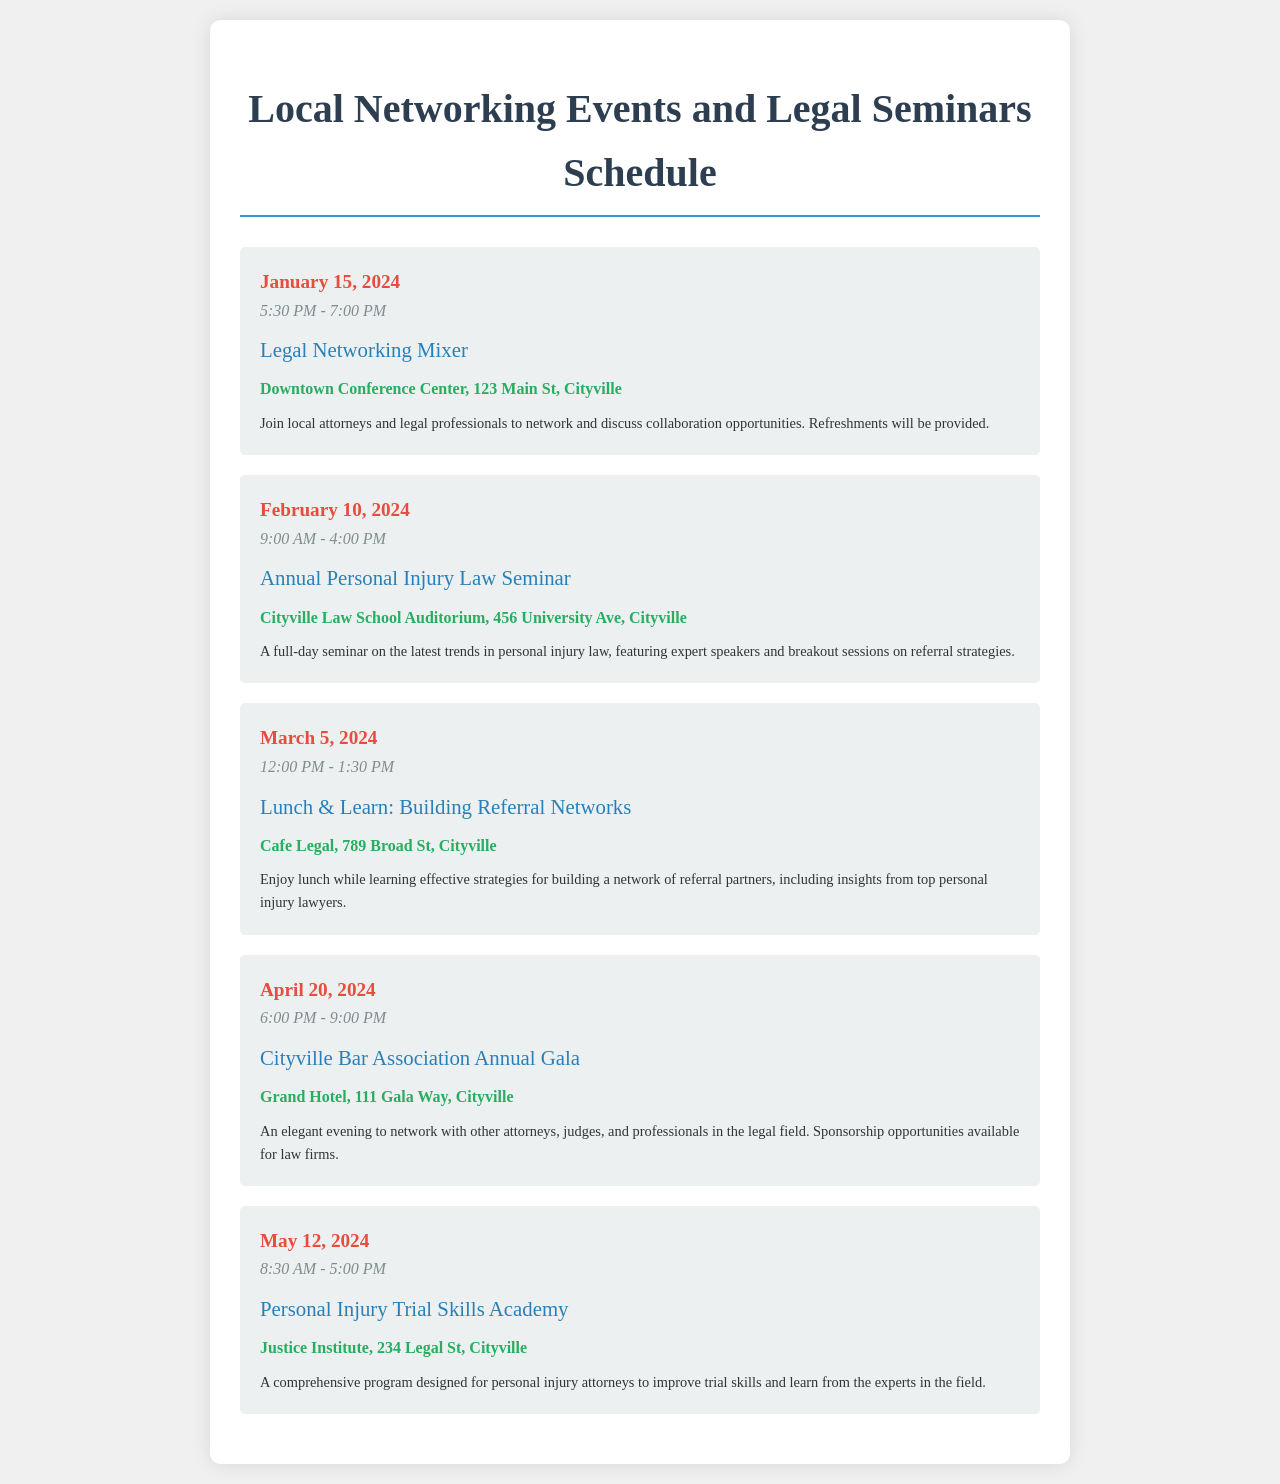What is the date of the Legal Networking Mixer? The Legal Networking Mixer is scheduled for January 15, 2024.
Answer: January 15, 2024 What time does the Annual Personal Injury Law Seminar start? The seminar starts at 9:00 AM.
Answer: 9:00 AM Where is the Lunch & Learn: Building Referral Networks taking place? The Lunch & Learn event is at Cafe Legal, located at 789 Broad St, Cityville.
Answer: Cafe Legal, 789 Broad St, Cityville What event takes place on April 20, 2024? The event on April 20, 2024, is the Cityville Bar Association Annual Gala.
Answer: Cityville Bar Association Annual Gala How long is the Personal Injury Trial Skills Academy? The Personal Injury Trial Skills Academy runs from 8:30 AM to 5:00 PM.
Answer: 8:30 AM - 5:00 PM How many events are listed in the schedule? There are five distinct events mentioned in the schedule.
Answer: Five What type of event is the May 12, 2024, event? The event on May 12, 2024, is a training program focused on trial skills for personal injury attorneys.
Answer: Trial Skills Academy Which event features expert speakers? The Annual Personal Injury Law Seminar features expert speakers.
Answer: Annual Personal Injury Law Seminar What is provided at the Legal Networking Mixer? Refreshments will be provided at the Legal Networking Mixer.
Answer: Refreshments 